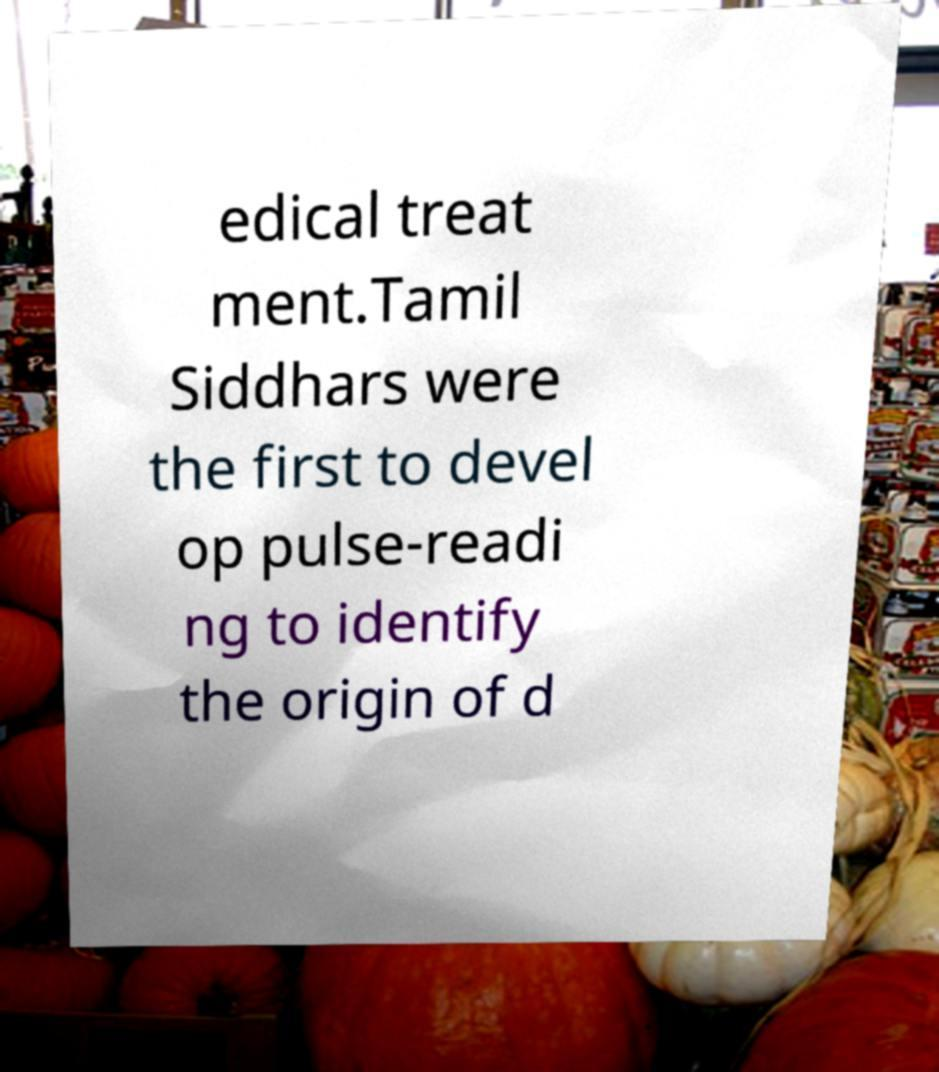Please read and relay the text visible in this image. What does it say? edical treat ment.Tamil Siddhars were the first to devel op pulse-readi ng to identify the origin of d 